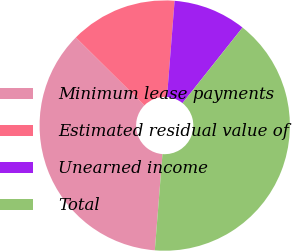Convert chart. <chart><loc_0><loc_0><loc_500><loc_500><pie_chart><fcel>Minimum lease payments<fcel>Estimated residual value of<fcel>Unearned income<fcel>Total<nl><fcel>36.17%<fcel>13.83%<fcel>9.42%<fcel>40.58%<nl></chart> 